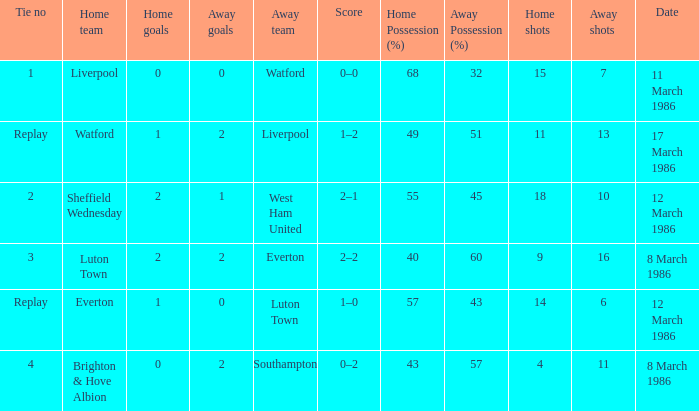What tie happened with Southampton? 4.0. 